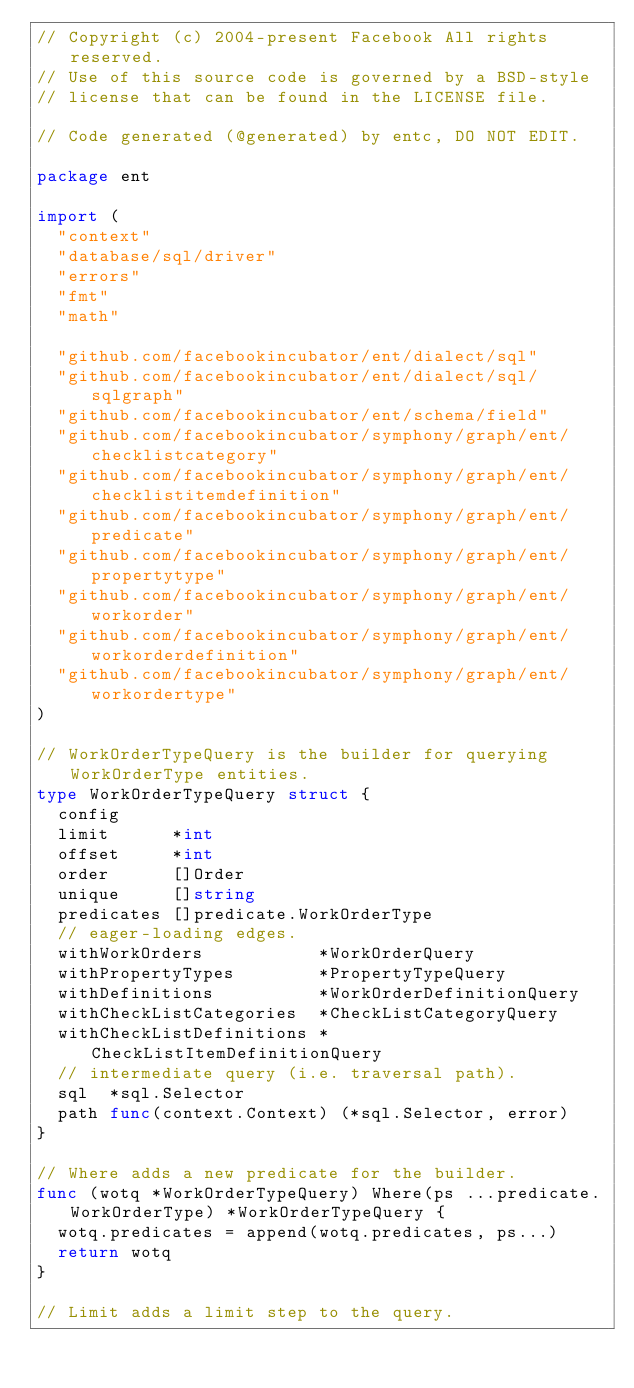Convert code to text. <code><loc_0><loc_0><loc_500><loc_500><_Go_>// Copyright (c) 2004-present Facebook All rights reserved.
// Use of this source code is governed by a BSD-style
// license that can be found in the LICENSE file.

// Code generated (@generated) by entc, DO NOT EDIT.

package ent

import (
	"context"
	"database/sql/driver"
	"errors"
	"fmt"
	"math"

	"github.com/facebookincubator/ent/dialect/sql"
	"github.com/facebookincubator/ent/dialect/sql/sqlgraph"
	"github.com/facebookincubator/ent/schema/field"
	"github.com/facebookincubator/symphony/graph/ent/checklistcategory"
	"github.com/facebookincubator/symphony/graph/ent/checklistitemdefinition"
	"github.com/facebookincubator/symphony/graph/ent/predicate"
	"github.com/facebookincubator/symphony/graph/ent/propertytype"
	"github.com/facebookincubator/symphony/graph/ent/workorder"
	"github.com/facebookincubator/symphony/graph/ent/workorderdefinition"
	"github.com/facebookincubator/symphony/graph/ent/workordertype"
)

// WorkOrderTypeQuery is the builder for querying WorkOrderType entities.
type WorkOrderTypeQuery struct {
	config
	limit      *int
	offset     *int
	order      []Order
	unique     []string
	predicates []predicate.WorkOrderType
	// eager-loading edges.
	withWorkOrders           *WorkOrderQuery
	withPropertyTypes        *PropertyTypeQuery
	withDefinitions          *WorkOrderDefinitionQuery
	withCheckListCategories  *CheckListCategoryQuery
	withCheckListDefinitions *CheckListItemDefinitionQuery
	// intermediate query (i.e. traversal path).
	sql  *sql.Selector
	path func(context.Context) (*sql.Selector, error)
}

// Where adds a new predicate for the builder.
func (wotq *WorkOrderTypeQuery) Where(ps ...predicate.WorkOrderType) *WorkOrderTypeQuery {
	wotq.predicates = append(wotq.predicates, ps...)
	return wotq
}

// Limit adds a limit step to the query.</code> 